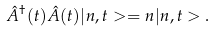<formula> <loc_0><loc_0><loc_500><loc_500>\hat { A } ^ { \dagger } ( t ) \hat { A } ( t ) | n , t > = n | n , t > .</formula> 